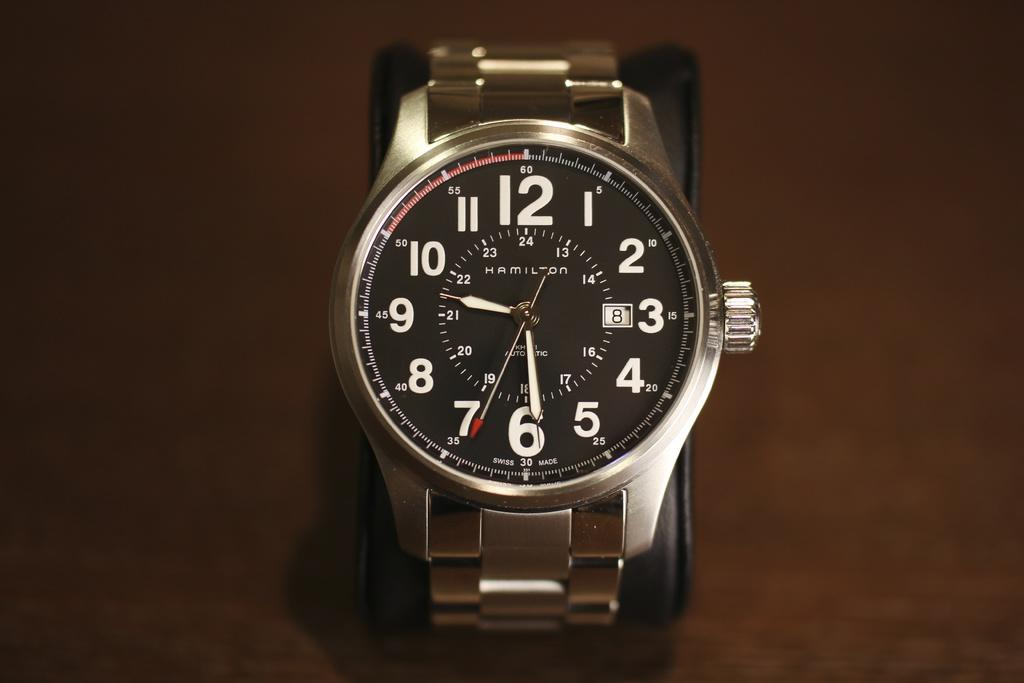<image>
Relay a brief, clear account of the picture shown. Hamilton automatic silver watch with numbers for the time 